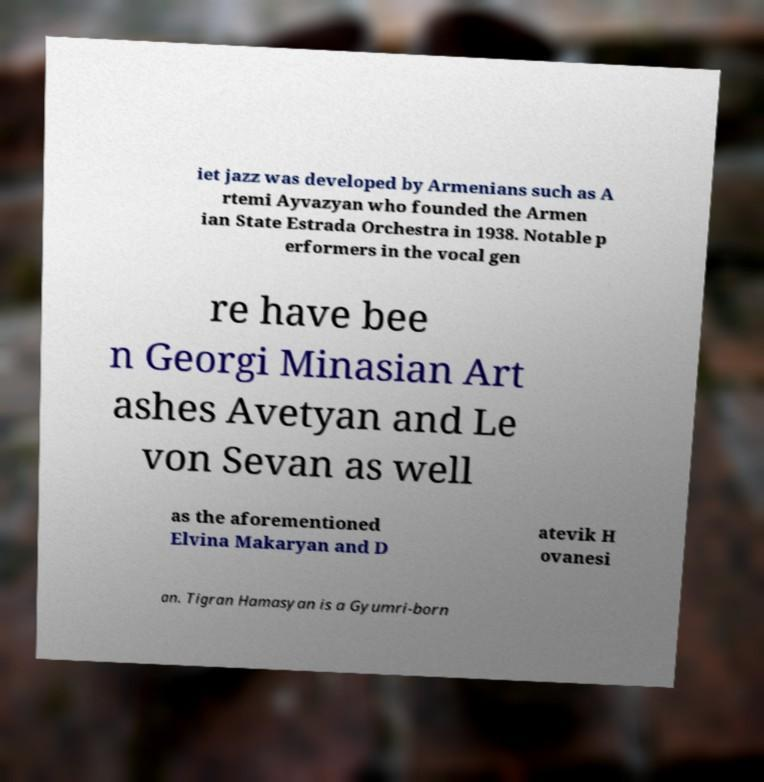I need the written content from this picture converted into text. Can you do that? iet jazz was developed by Armenians such as A rtemi Ayvazyan who founded the Armen ian State Estrada Orchestra in 1938. Notable p erformers in the vocal gen re have bee n Georgi Minasian Art ashes Avetyan and Le von Sevan as well as the aforementioned Elvina Makaryan and D atevik H ovanesi an. Tigran Hamasyan is a Gyumri-born 